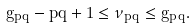Convert formula to latex. <formula><loc_0><loc_0><loc_500><loc_500>g _ { p q } - p q + 1 \leq \nu _ { p q } \leq g _ { p q } .</formula> 